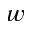<formula> <loc_0><loc_0><loc_500><loc_500>_ { w }</formula> 